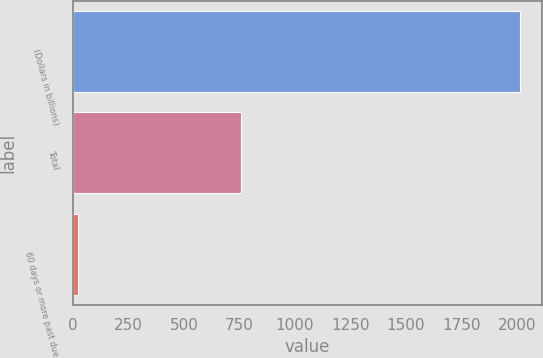<chart> <loc_0><loc_0><loc_500><loc_500><bar_chart><fcel>(Dollars in billions)<fcel>Total<fcel>60 days or more past due<nl><fcel>2012<fcel>755<fcel>22<nl></chart> 